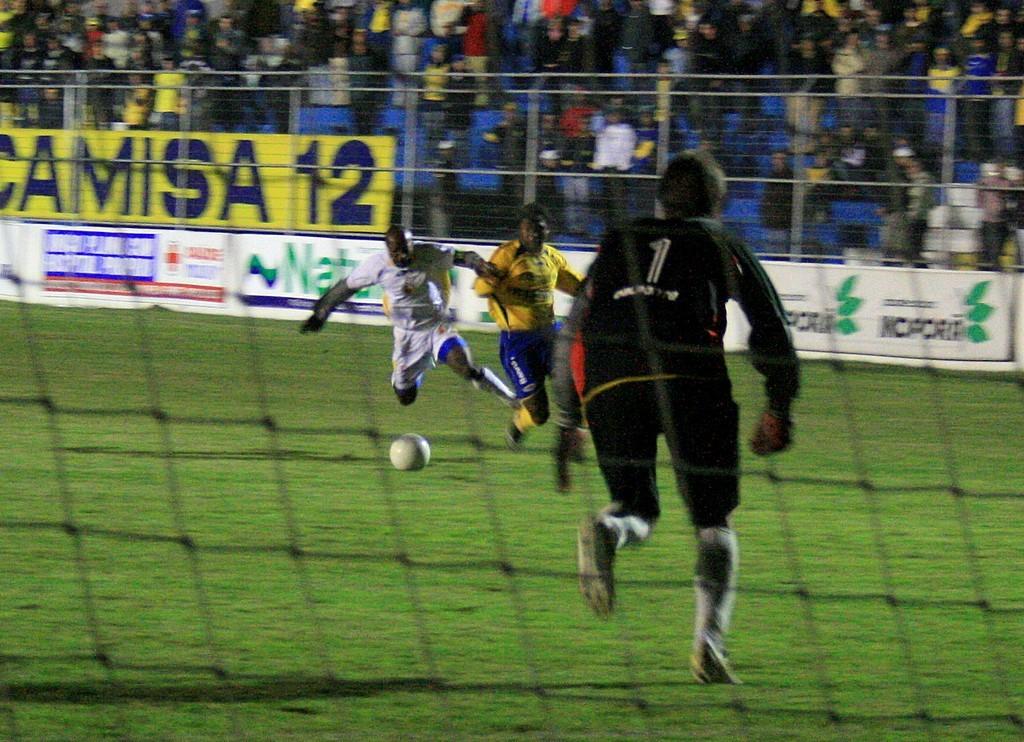What is the number on the black jersey?
Offer a terse response. 1. 